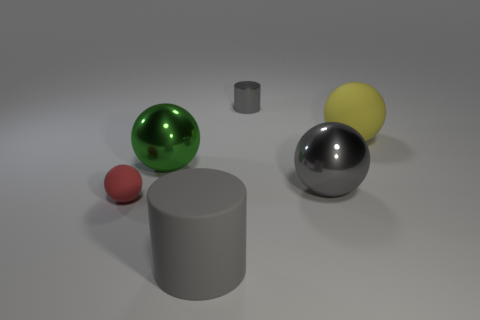Are there more tiny shiny things behind the big gray matte cylinder than tiny blue matte cylinders?
Make the answer very short. Yes. How many objects are big gray things right of the small red matte sphere or gray things?
Your answer should be very brief. 3. How many large green balls have the same material as the large gray ball?
Your response must be concise. 1. What shape is the large metallic object that is the same color as the large rubber cylinder?
Give a very brief answer. Sphere. Is there a small gray thing of the same shape as the big gray matte thing?
Offer a very short reply. Yes. What shape is the gray shiny thing that is the same size as the red matte thing?
Offer a terse response. Cylinder. There is a tiny metal thing; is it the same color as the big matte thing in front of the big green ball?
Provide a short and direct response. Yes. What number of metallic balls are on the right side of the gray object in front of the small red object?
Make the answer very short. 1. There is a sphere that is both left of the large gray sphere and right of the small matte thing; how big is it?
Offer a terse response. Large. Is there a metal object of the same size as the gray metal ball?
Your answer should be very brief. Yes. 